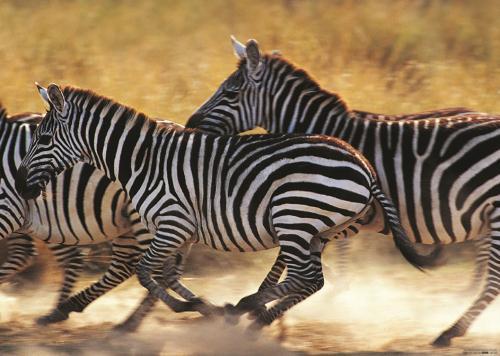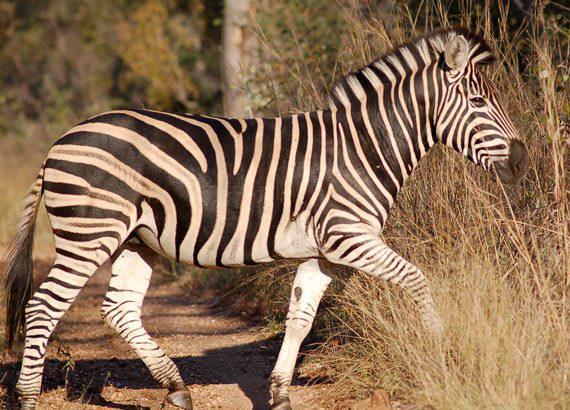The first image is the image on the left, the second image is the image on the right. Examine the images to the left and right. Is the description "Each image contains multiple zebras, and one image shows exactly two zebras posed with one's head over the other's back." accurate? Answer yes or no. No. The first image is the image on the left, the second image is the image on the right. Analyze the images presented: Is the assertion "The right image contains no more than two zebras." valid? Answer yes or no. Yes. 